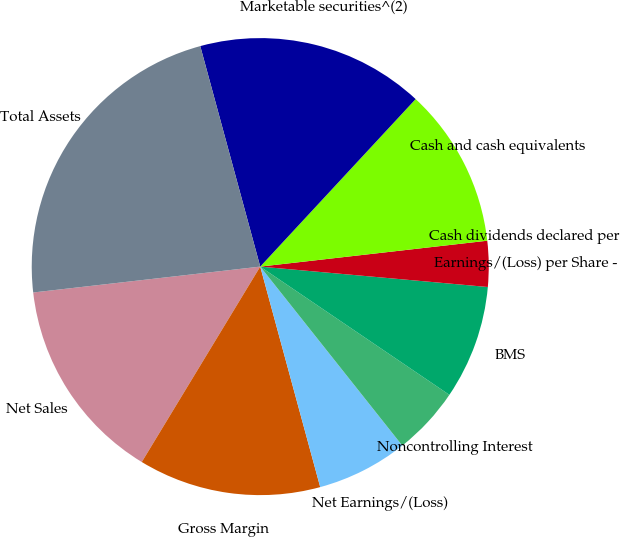Convert chart. <chart><loc_0><loc_0><loc_500><loc_500><pie_chart><fcel>Net Sales<fcel>Gross Margin<fcel>Net Earnings/(Loss)<fcel>Noncontrolling Interest<fcel>BMS<fcel>Earnings/(Loss) per Share -<fcel>Cash dividends declared per<fcel>Cash and cash equivalents<fcel>Marketable securities^(2)<fcel>Total Assets<nl><fcel>14.52%<fcel>12.9%<fcel>6.45%<fcel>4.84%<fcel>8.06%<fcel>3.23%<fcel>0.0%<fcel>11.29%<fcel>16.13%<fcel>22.58%<nl></chart> 